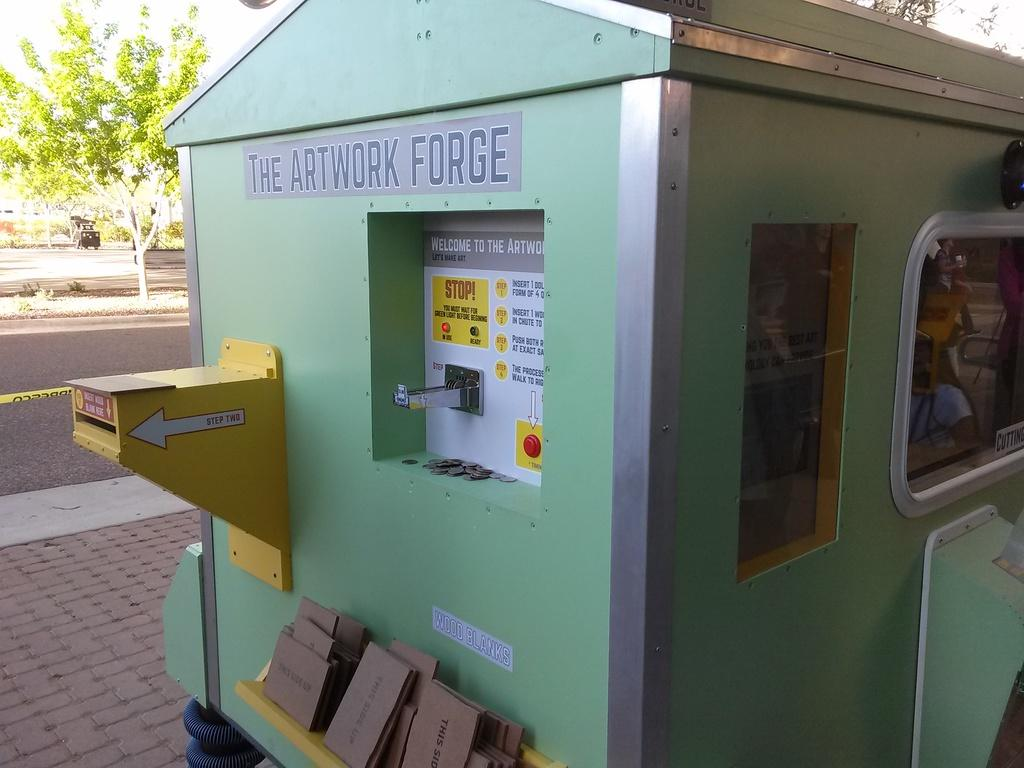What color is the machine in the image? The machine in the image is green-colored. What can be seen on the left side of the image? There is a road and a green tree on the left side of the image. What type of path is visible at the bottom of the image? There is a footpath at the bottom of the image. What type of grain is being processed by the machine in the image? There is no indication of any grain or processing in the image; it only shows a green-colored machine, a road, a green tree, and a footpath. 